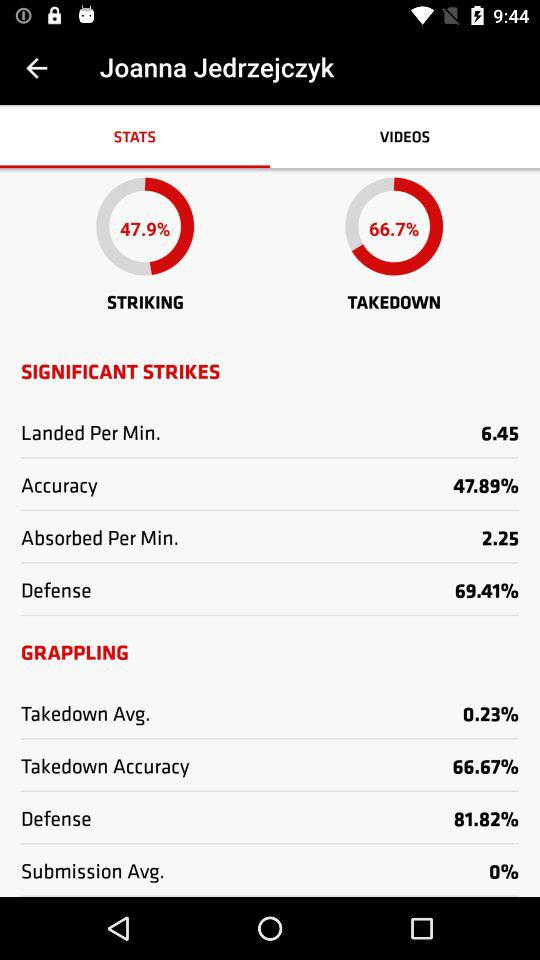What is the accuracy percentage? The accuracy percentage is 47.89%. 